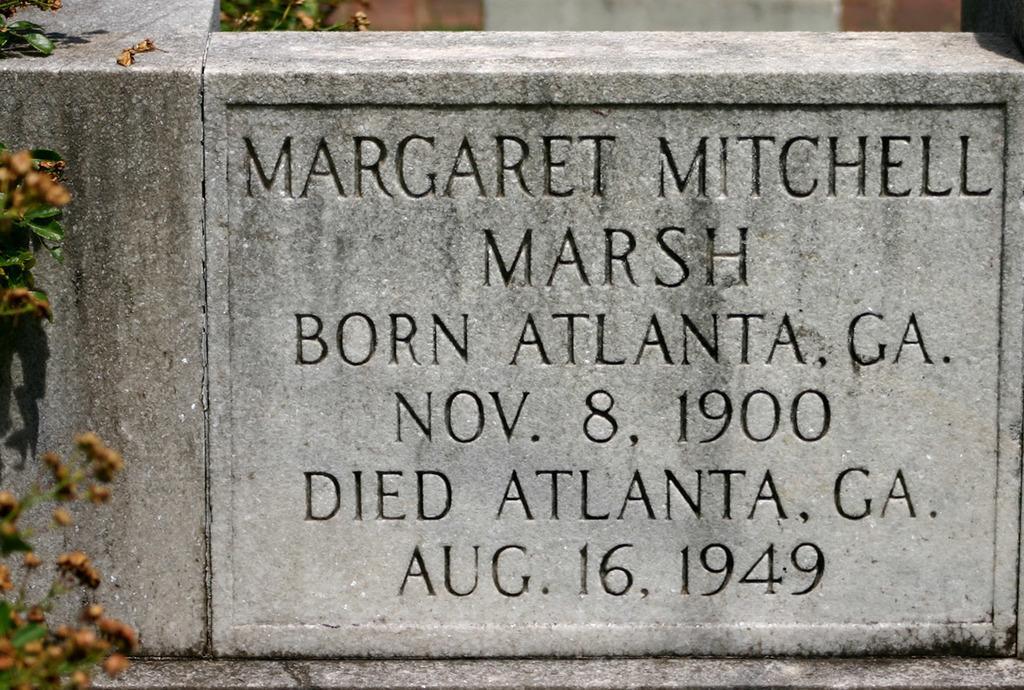In one or two sentences, can you explain what this image depicts? In this image we can see a memorial stone. On the left side of the image we can see leaves and buds. 